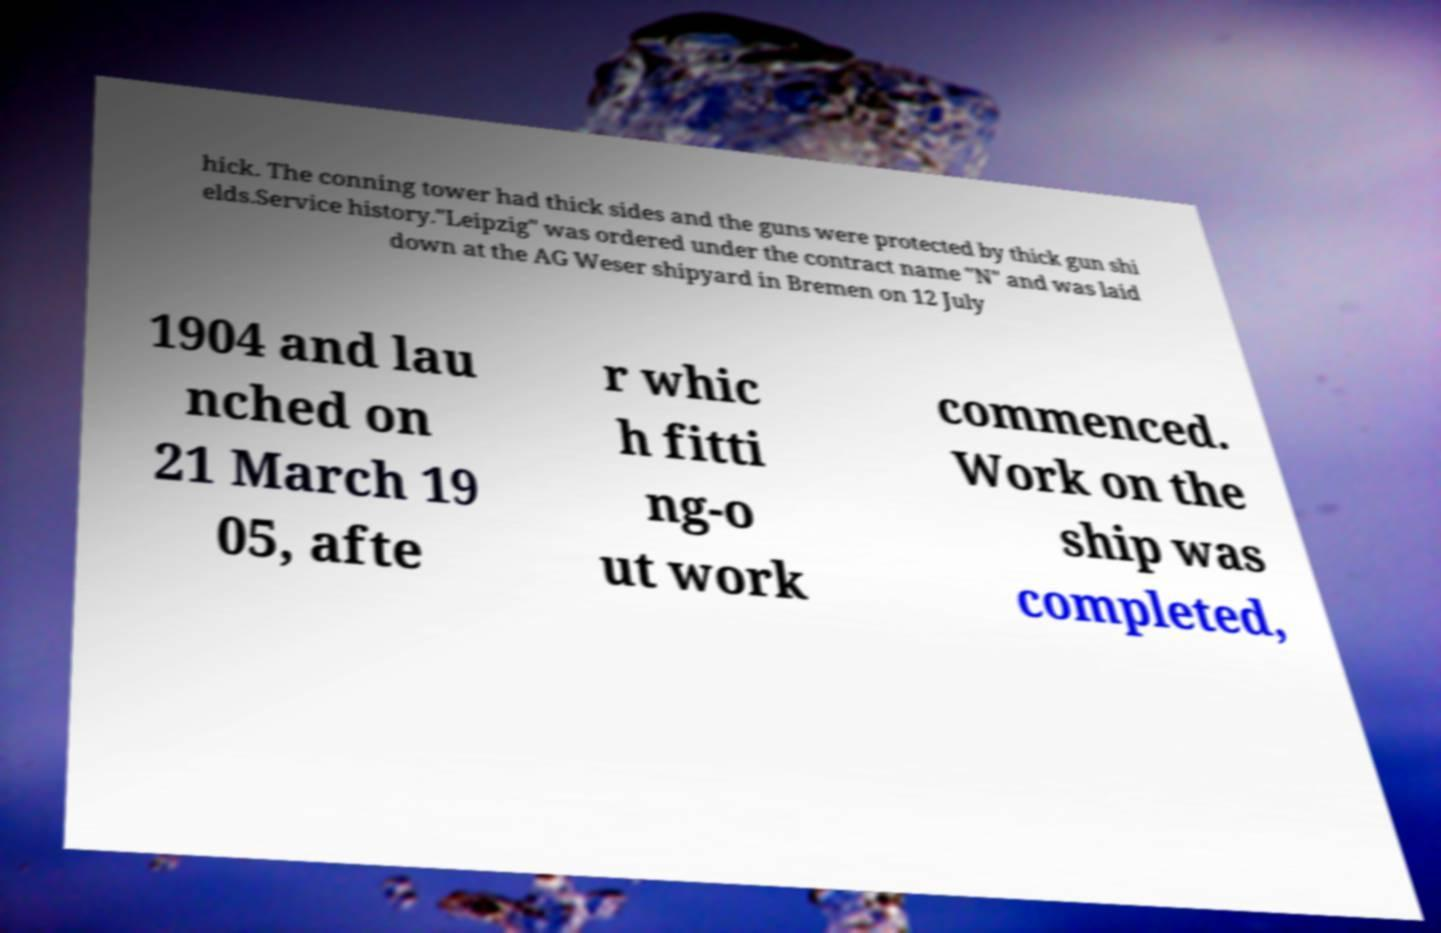Can you accurately transcribe the text from the provided image for me? hick. The conning tower had thick sides and the guns were protected by thick gun shi elds.Service history."Leipzig" was ordered under the contract name "N" and was laid down at the AG Weser shipyard in Bremen on 12 July 1904 and lau nched on 21 March 19 05, afte r whic h fitti ng-o ut work commenced. Work on the ship was completed, 